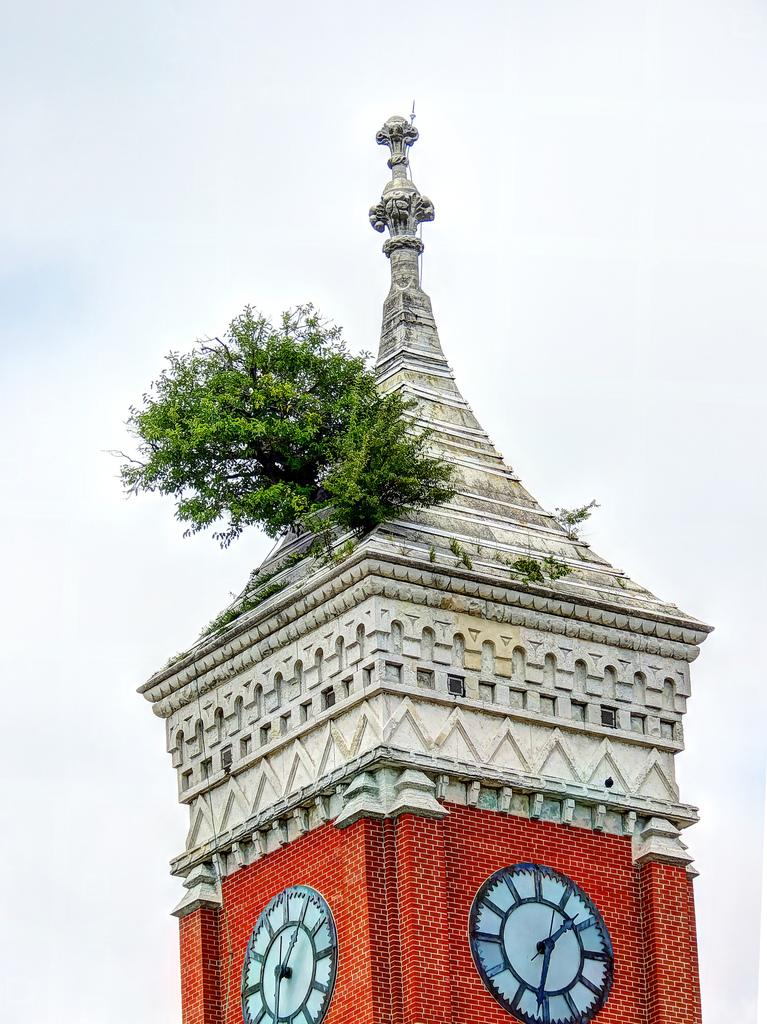What is the main structure in the image? There is a clock tower in the image. Is there any vegetation associated with the clock tower? Yes, there is a plant associated with the clock tower. What is visible in the background of the image? The sky is visible in the background of the image. What type of skin is visible on the clock tower in the image? The clock tower is an inanimate object and does not have skin; it is made of materials such as stone or metal. How many times has the clock tower been copied in the image? The image does not depict the clock tower being copied; it shows the original clock tower. 